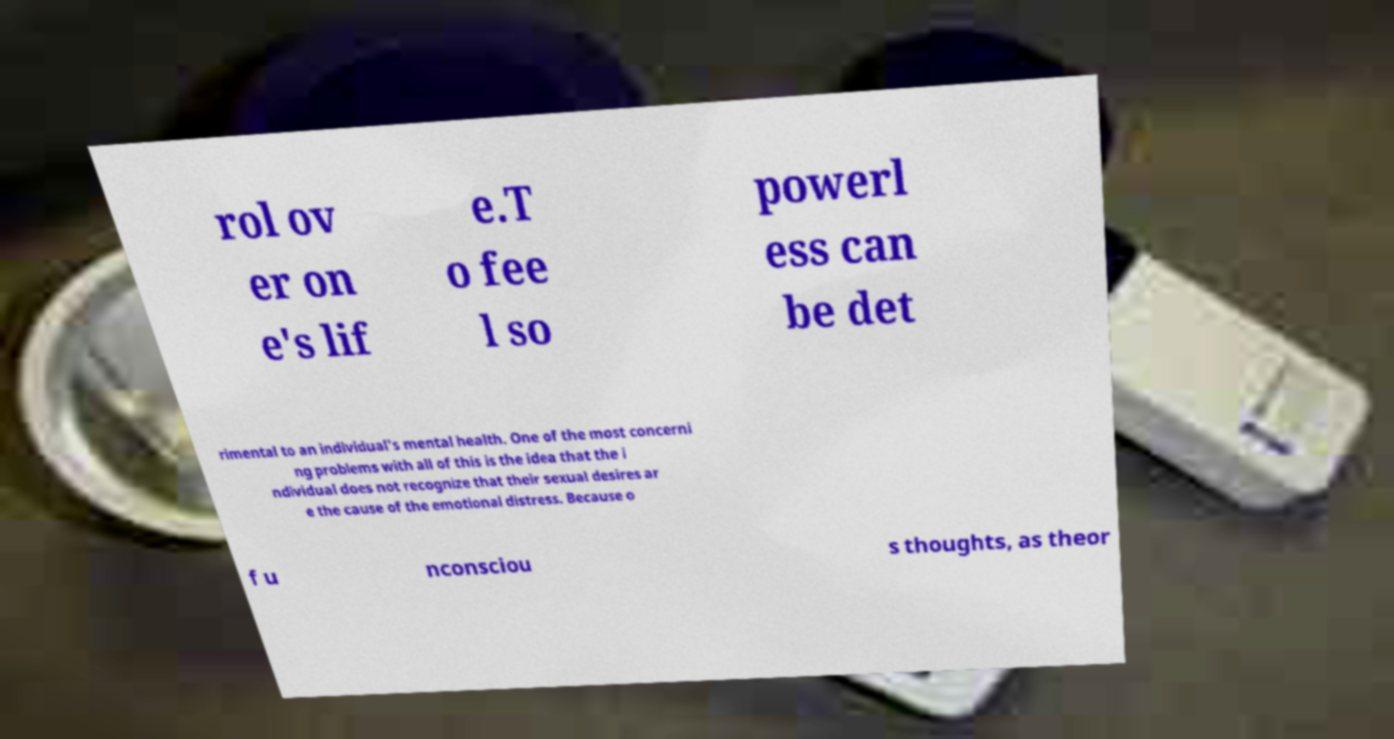I need the written content from this picture converted into text. Can you do that? rol ov er on e's lif e.T o fee l so powerl ess can be det rimental to an individual's mental health. One of the most concerni ng problems with all of this is the idea that the i ndividual does not recognize that their sexual desires ar e the cause of the emotional distress. Because o f u nconsciou s thoughts, as theor 